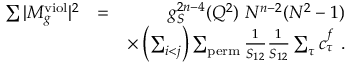<formula> <loc_0><loc_0><loc_500><loc_500>\begin{array} { r l r } { \sum | M _ { g } ^ { v i o l } | ^ { 2 } } & { = } & { g _ { S } ^ { 2 n - 4 } ( Q ^ { 2 } ) N ^ { n - 2 } ( N ^ { 2 } - 1 ) } \\ & { \times \left ( \sum _ { i < j } \right ) \sum _ { p e r m } \frac { 1 } { S _ { 1 2 } } \frac { 1 } { S _ { 1 2 } } \sum _ { \tau } c _ { \tau } ^ { f } . } \end{array}</formula> 